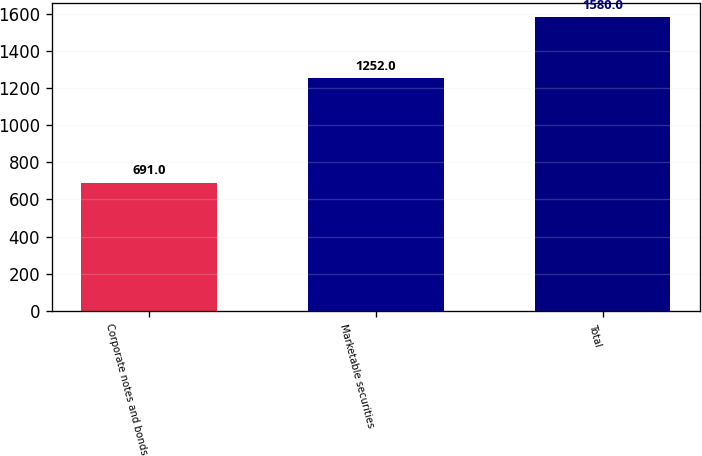Convert chart to OTSL. <chart><loc_0><loc_0><loc_500><loc_500><bar_chart><fcel>Corporate notes and bonds<fcel>Marketable securities<fcel>Total<nl><fcel>691<fcel>1252<fcel>1580<nl></chart> 